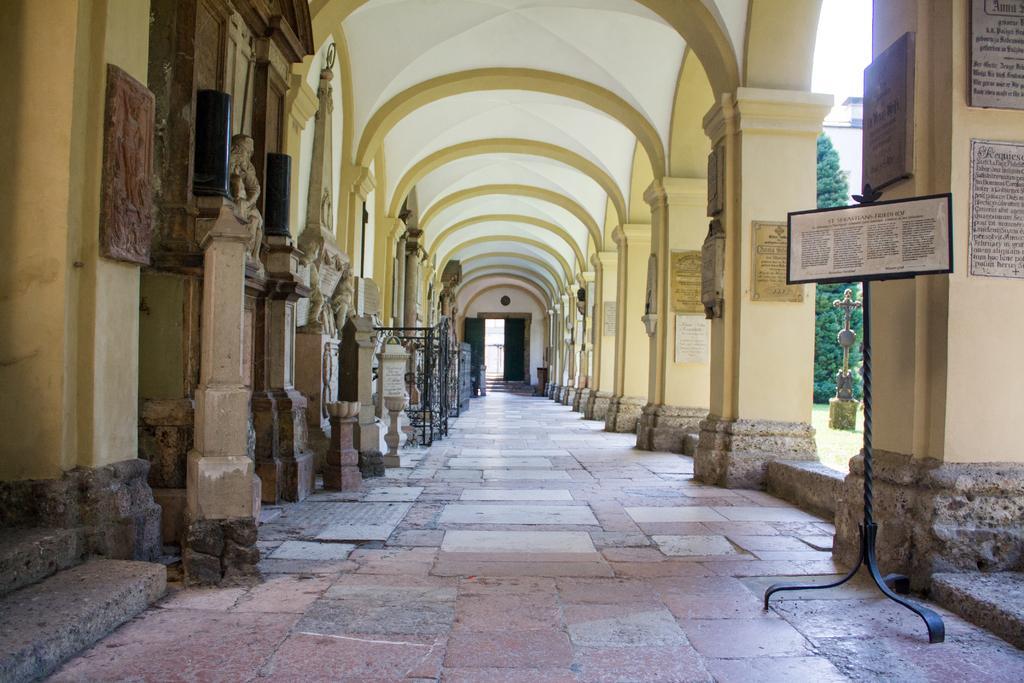Describe this image in one or two sentences. In this picture we can see stands on the floor, pillars, boards, statues, ceiling and some objects and in the background we can see a tree, cross. 